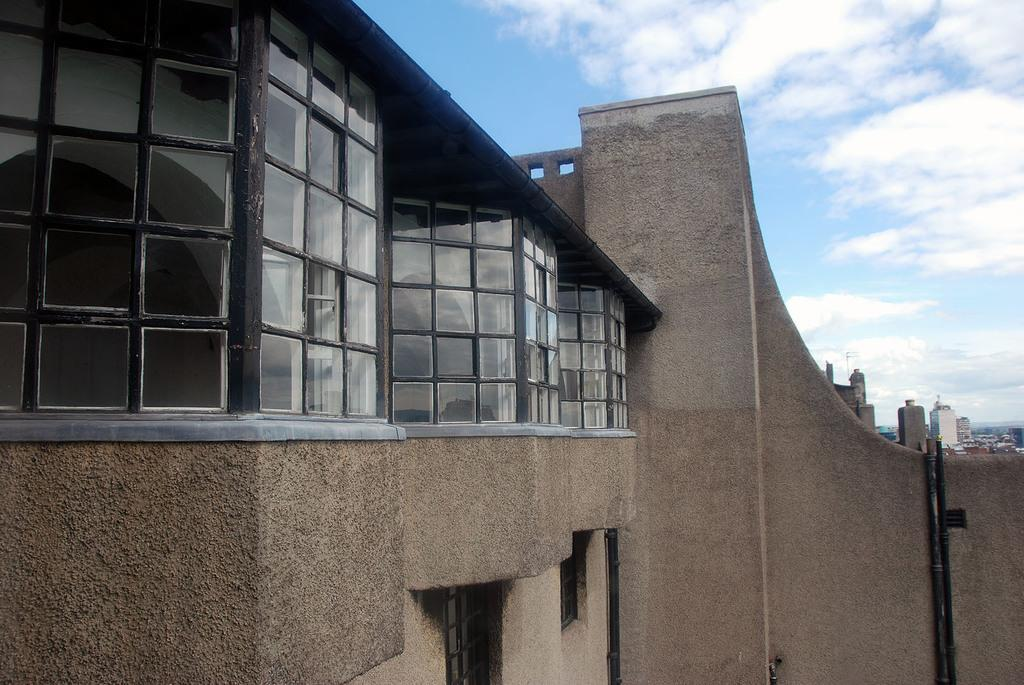What type of structures can be seen in the image? There are buildings in the image. What is one specific feature of these structures? There are windows in the image. Can you describe any other objects or elements in the image? There is a wall, a pole, and pipes visible in the image. What is visible in the sky at the top of the image? Clouds are visible in the sky at the top of the image. How many wings can be seen on the buildings in the image? There are no wings visible on the buildings in the image. What type of lock is used on the doors of the buildings in the image? There is no information about locks or doors on the buildings in the image. 